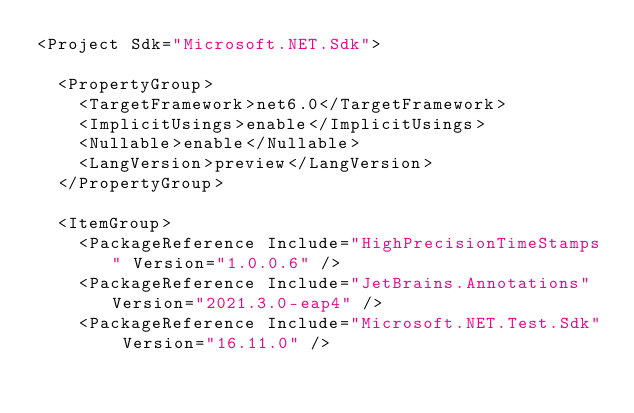Convert code to text. <code><loc_0><loc_0><loc_500><loc_500><_XML_><Project Sdk="Microsoft.NET.Sdk">

  <PropertyGroup>
    <TargetFramework>net6.0</TargetFramework>
    <ImplicitUsings>enable</ImplicitUsings>
    <Nullable>enable</Nullable>
    <LangVersion>preview</LangVersion>
  </PropertyGroup>

  <ItemGroup>
    <PackageReference Include="HighPrecisionTimeStamps" Version="1.0.0.6" />
    <PackageReference Include="JetBrains.Annotations" Version="2021.3.0-eap4" />
    <PackageReference Include="Microsoft.NET.Test.Sdk" Version="16.11.0" /></code> 